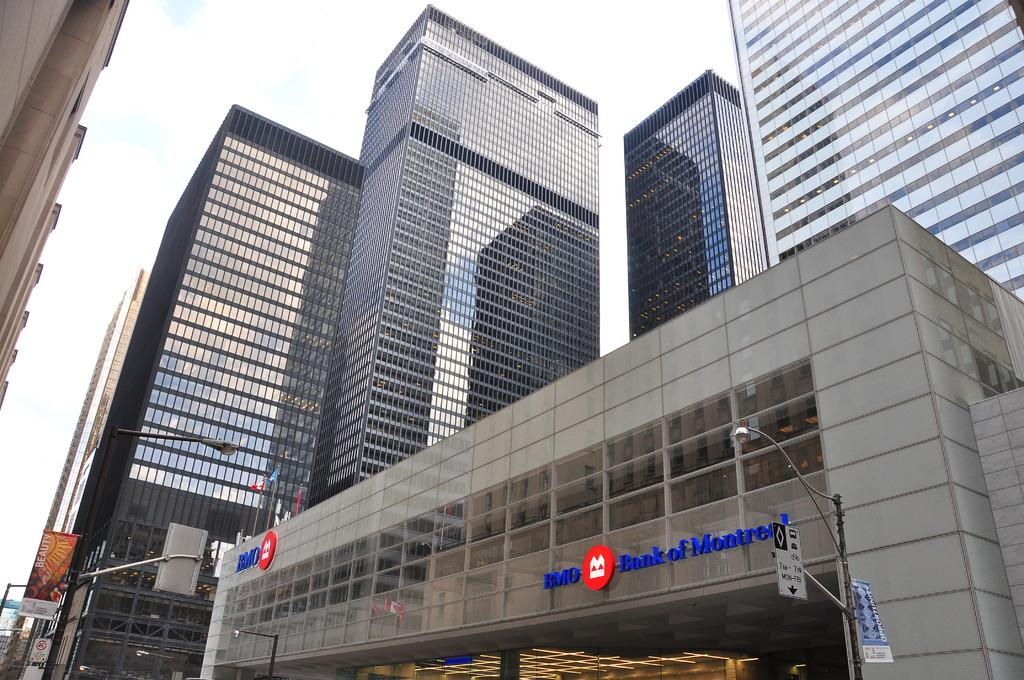Provide a one-sentence caption for the provided image. The outside of a BMO Bank of Montreal building. 